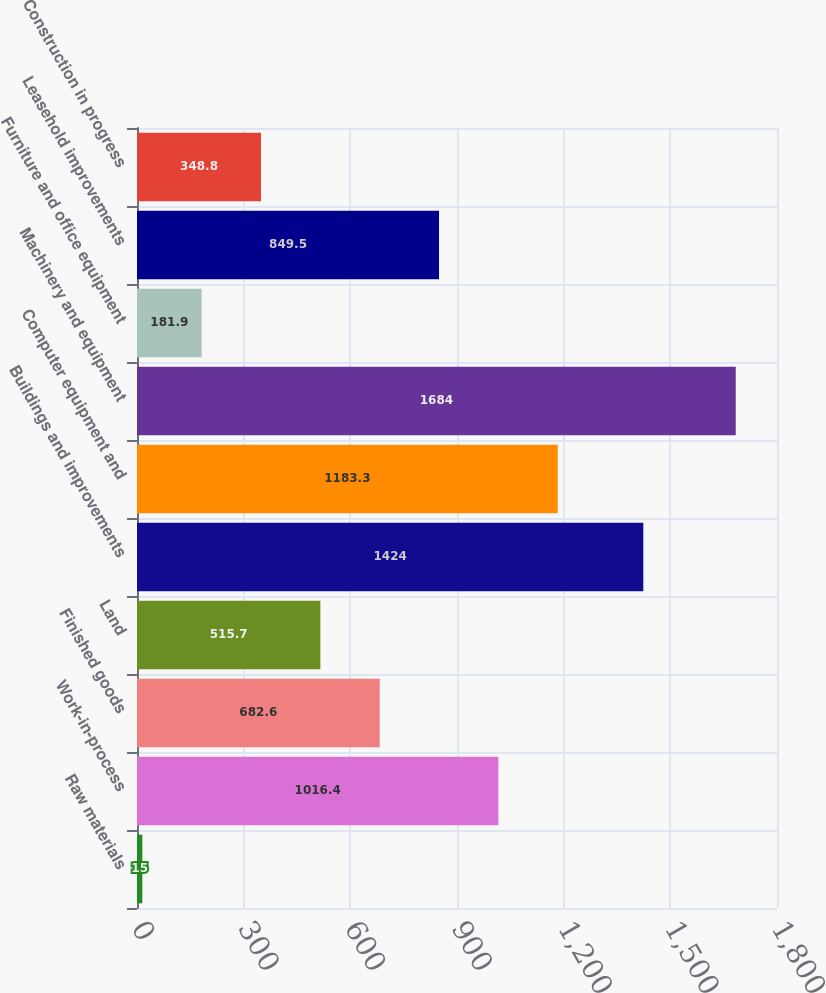Convert chart to OTSL. <chart><loc_0><loc_0><loc_500><loc_500><bar_chart><fcel>Raw materials<fcel>Work-in-process<fcel>Finished goods<fcel>Land<fcel>Buildings and improvements<fcel>Computer equipment and<fcel>Machinery and equipment<fcel>Furniture and office equipment<fcel>Leasehold improvements<fcel>Construction in progress<nl><fcel>15<fcel>1016.4<fcel>682.6<fcel>515.7<fcel>1424<fcel>1183.3<fcel>1684<fcel>181.9<fcel>849.5<fcel>348.8<nl></chart> 